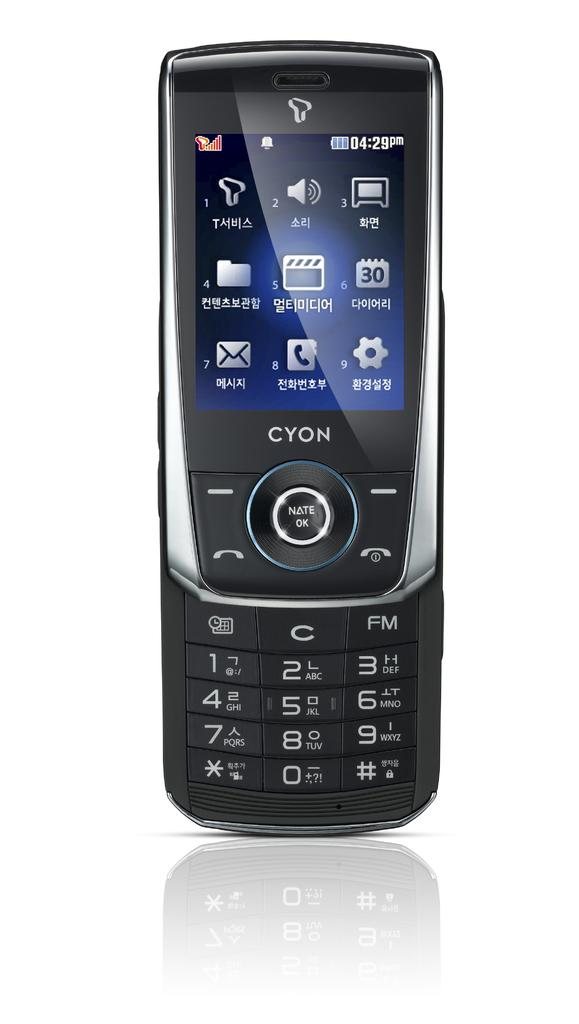What is the main subject of the image? There is a mobile in the center of the image. What type of glass is used to create the mobile in the image? There is no information about the material used to create the mobile in the image, and therefore we cannot determine if glass is used. What type of amusement can be seen in the image? There is no amusement or entertainment activity depicted in the image; it only features a mobile. 